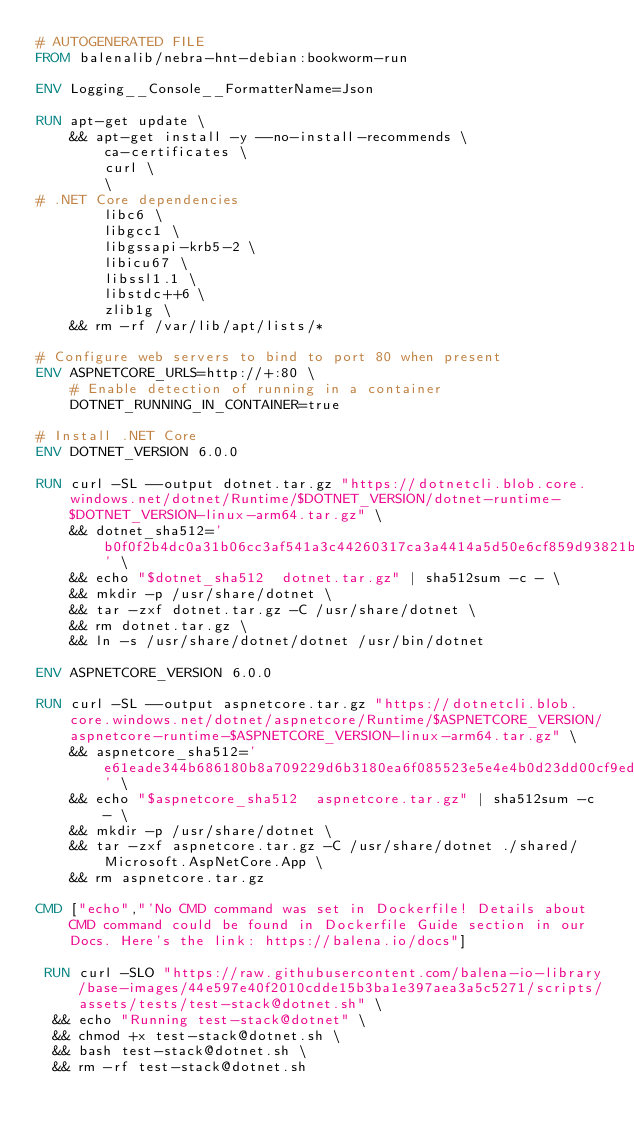Convert code to text. <code><loc_0><loc_0><loc_500><loc_500><_Dockerfile_># AUTOGENERATED FILE
FROM balenalib/nebra-hnt-debian:bookworm-run

ENV Logging__Console__FormatterName=Json

RUN apt-get update \
    && apt-get install -y --no-install-recommends \
        ca-certificates \
        curl \
        \
# .NET Core dependencies
        libc6 \
        libgcc1 \
        libgssapi-krb5-2 \
        libicu67 \
        libssl1.1 \
        libstdc++6 \
        zlib1g \
    && rm -rf /var/lib/apt/lists/*

# Configure web servers to bind to port 80 when present
ENV ASPNETCORE_URLS=http://+:80 \
    # Enable detection of running in a container
    DOTNET_RUNNING_IN_CONTAINER=true

# Install .NET Core
ENV DOTNET_VERSION 6.0.0

RUN curl -SL --output dotnet.tar.gz "https://dotnetcli.blob.core.windows.net/dotnet/Runtime/$DOTNET_VERSION/dotnet-runtime-$DOTNET_VERSION-linux-arm64.tar.gz" \
    && dotnet_sha512='b0f0f2b4dc0a31b06cc3af541a3c44260317ca3a4414a5d50e6cf859d93821b3d2c2246baec9f96004aeb1eb0e353631283b11cf3acc134d4694f0ed71c9503d' \
    && echo "$dotnet_sha512  dotnet.tar.gz" | sha512sum -c - \
    && mkdir -p /usr/share/dotnet \
    && tar -zxf dotnet.tar.gz -C /usr/share/dotnet \
    && rm dotnet.tar.gz \
    && ln -s /usr/share/dotnet/dotnet /usr/bin/dotnet

ENV ASPNETCORE_VERSION 6.0.0

RUN curl -SL --output aspnetcore.tar.gz "https://dotnetcli.blob.core.windows.net/dotnet/aspnetcore/Runtime/$ASPNETCORE_VERSION/aspnetcore-runtime-$ASPNETCORE_VERSION-linux-arm64.tar.gz" \
    && aspnetcore_sha512='e61eade344b686180b8a709229d6b3180ea6f085523e5e4e4b0d23dd00cf9edce3e51a920c986b1bab7d04d8cab5aae219c3b533b6feb84b32a02810936859b0' \
    && echo "$aspnetcore_sha512  aspnetcore.tar.gz" | sha512sum -c - \
    && mkdir -p /usr/share/dotnet \
    && tar -zxf aspnetcore.tar.gz -C /usr/share/dotnet ./shared/Microsoft.AspNetCore.App \
    && rm aspnetcore.tar.gz

CMD ["echo","'No CMD command was set in Dockerfile! Details about CMD command could be found in Dockerfile Guide section in our Docs. Here's the link: https://balena.io/docs"]

 RUN curl -SLO "https://raw.githubusercontent.com/balena-io-library/base-images/44e597e40f2010cdde15b3ba1e397aea3a5c5271/scripts/assets/tests/test-stack@dotnet.sh" \
  && echo "Running test-stack@dotnet" \
  && chmod +x test-stack@dotnet.sh \
  && bash test-stack@dotnet.sh \
  && rm -rf test-stack@dotnet.sh 
</code> 